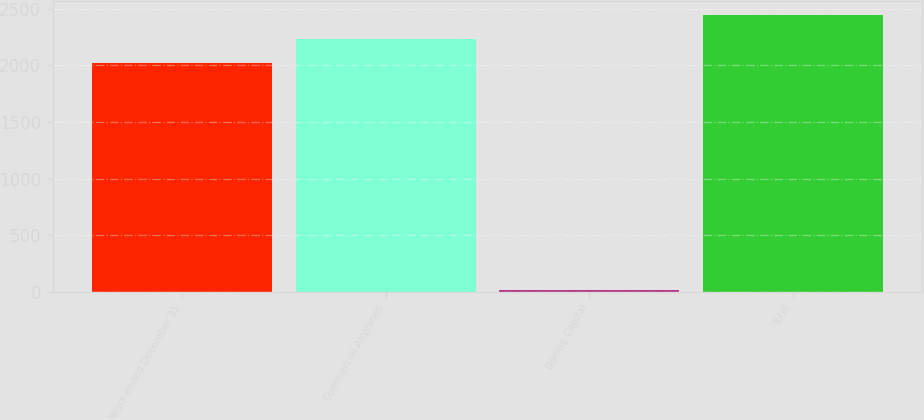Convert chart to OTSL. <chart><loc_0><loc_0><loc_500><loc_500><bar_chart><fcel>Years ended December 31<fcel>Commercial Airplanes<fcel>Boeing Capital<fcel>Total<nl><fcel>2016<fcel>2230.2<fcel>16<fcel>2444.4<nl></chart> 